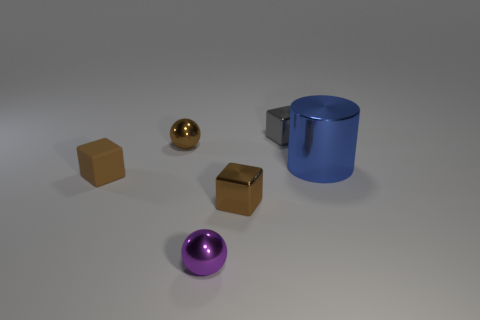Add 2 big cylinders. How many objects exist? 8 Subtract all brown metal blocks. How many blocks are left? 2 Subtract 1 cylinders. How many cylinders are left? 0 Subtract all gray cubes. How many cubes are left? 2 Subtract 0 red balls. How many objects are left? 6 Subtract all spheres. How many objects are left? 4 Subtract all blue blocks. Subtract all yellow balls. How many blocks are left? 3 Subtract all cyan cubes. How many brown balls are left? 1 Subtract all big blue cylinders. Subtract all blue cylinders. How many objects are left? 4 Add 5 tiny brown objects. How many tiny brown objects are left? 8 